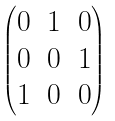Convert formula to latex. <formula><loc_0><loc_0><loc_500><loc_500>\begin{pmatrix} 0 & 1 & 0 \\ 0 & 0 & 1 \\ 1 & 0 & 0 \end{pmatrix}</formula> 